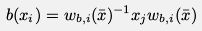<formula> <loc_0><loc_0><loc_500><loc_500>b ( x _ { i } ) = w _ { b , i } ( \bar { x } ) ^ { - 1 } x _ { j } w _ { b , i } ( \bar { x } )</formula> 